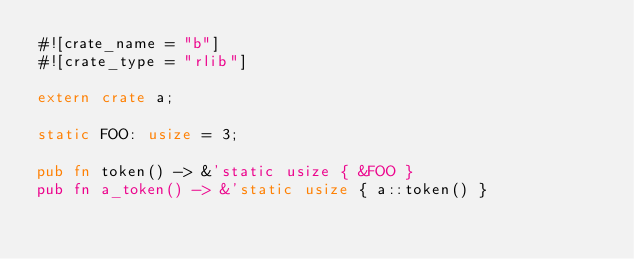Convert code to text. <code><loc_0><loc_0><loc_500><loc_500><_Rust_>#![crate_name = "b"]
#![crate_type = "rlib"]

extern crate a;

static FOO: usize = 3;

pub fn token() -> &'static usize { &FOO }
pub fn a_token() -> &'static usize { a::token() }
</code> 